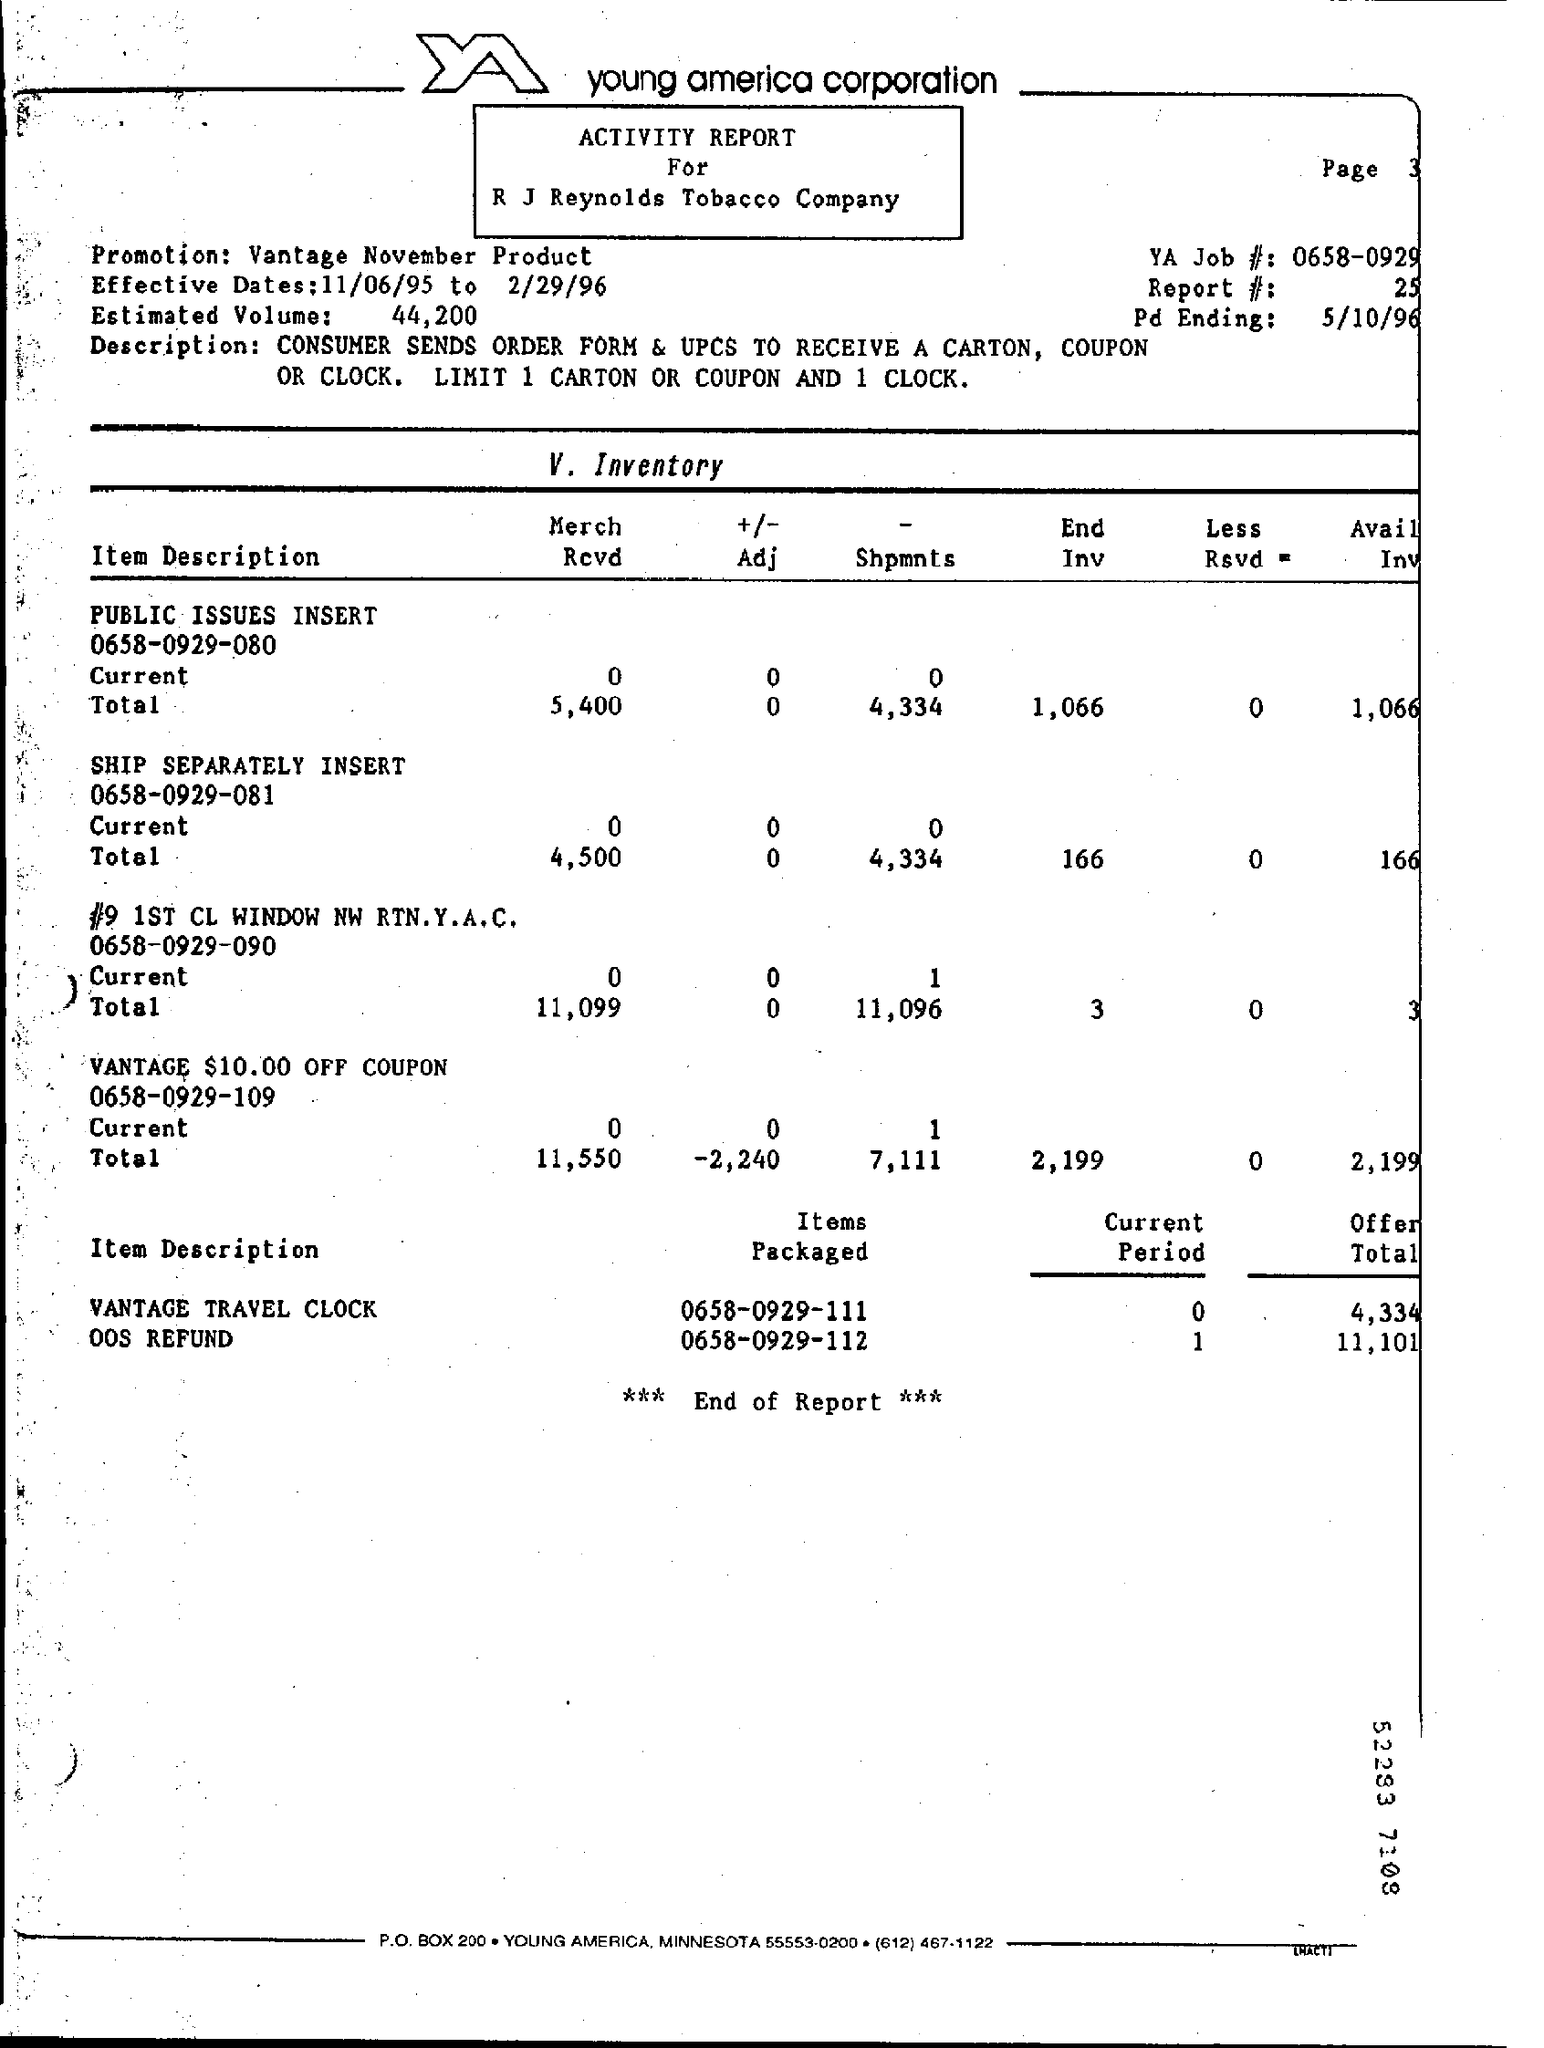Draw attention to some important aspects in this diagram. Vantage November Product Promotion: The Offer Total for Vantage Travel Clock is 4,334. The Report number is 25. The current period for the Vantage Travel Clock is currently unknown, ranging from 0 to... The estimated volume is approximately 44,200. 